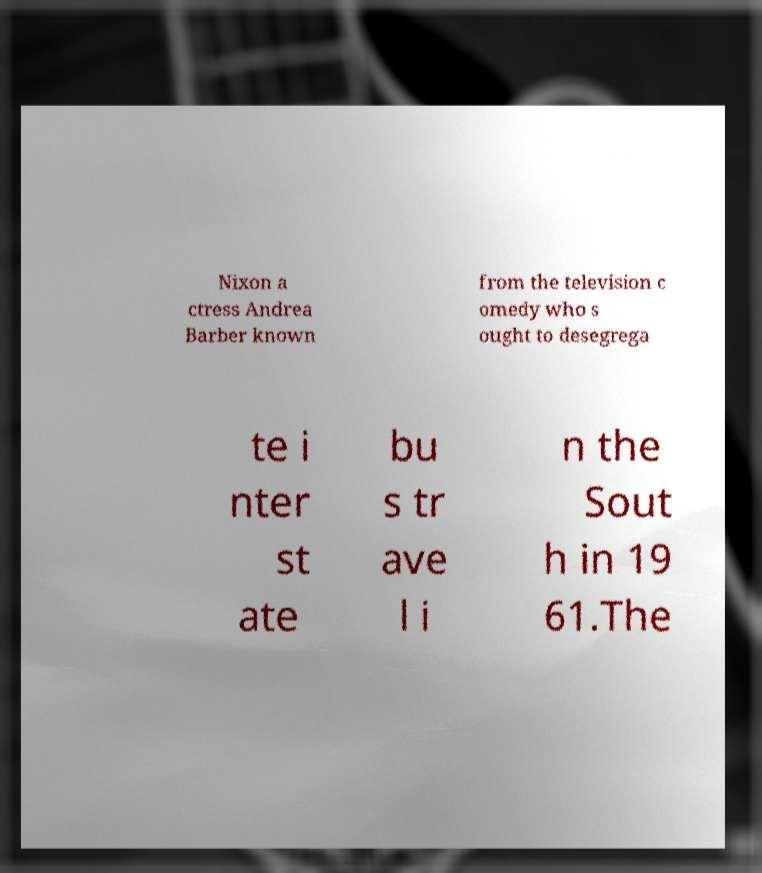Please read and relay the text visible in this image. What does it say? Nixon a ctress Andrea Barber known from the television c omedy who s ought to desegrega te i nter st ate bu s tr ave l i n the Sout h in 19 61.The 